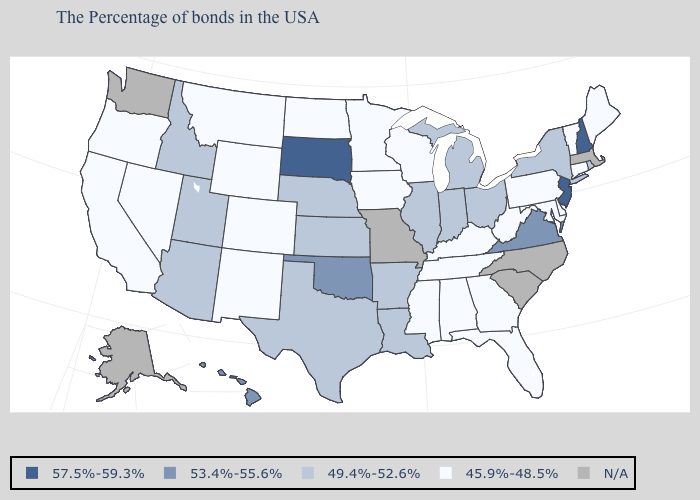Is the legend a continuous bar?
Short answer required. No. What is the value of Florida?
Quick response, please. 45.9%-48.5%. What is the value of Wyoming?
Be succinct. 45.9%-48.5%. Name the states that have a value in the range 57.5%-59.3%?
Concise answer only. New Hampshire, New Jersey, South Dakota. What is the value of New Mexico?
Concise answer only. 45.9%-48.5%. Among the states that border New York , which have the lowest value?
Write a very short answer. Vermont, Connecticut, Pennsylvania. What is the lowest value in states that border Maryland?
Keep it brief. 45.9%-48.5%. Name the states that have a value in the range 53.4%-55.6%?
Answer briefly. Virginia, Oklahoma, Hawaii. What is the value of Wisconsin?
Give a very brief answer. 45.9%-48.5%. Name the states that have a value in the range 53.4%-55.6%?
Write a very short answer. Virginia, Oklahoma, Hawaii. Is the legend a continuous bar?
Quick response, please. No. What is the value of Alabama?
Short answer required. 45.9%-48.5%. 